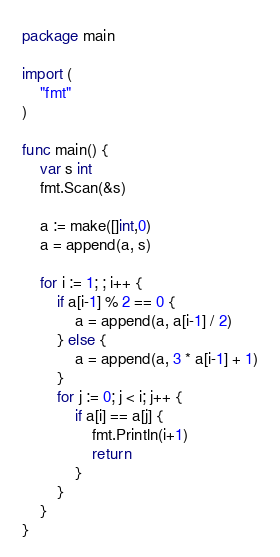Convert code to text. <code><loc_0><loc_0><loc_500><loc_500><_Go_>package main

import (
	"fmt"
)

func main() {
	var s int
	fmt.Scan(&s)
	
  	a := make([]int,0)
  	a = append(a, s)
  	
	for i := 1; ; i++ {
		if a[i-1] % 2 == 0 {
			a = append(a, a[i-1] / 2)
		} else {
			a = append(a, 3 * a[i-1] + 1)
		}
		for j := 0; j < i; j++ {
			if a[i] == a[j] {
				fmt.Println(i+1)
				return
			}
		}
	}
}</code> 